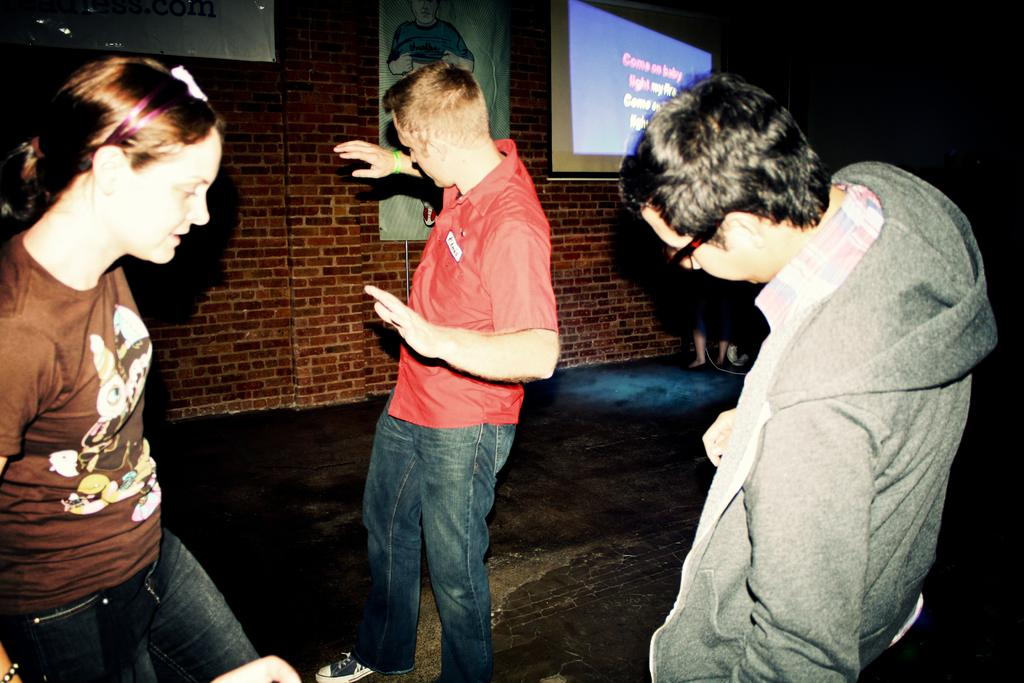Who or what can be seen in the image? There are people in the image. What can be seen in the background of the image? There are posts on a wall in the background of the image. What is the main object in the foreground of the image? There is a projector screen in the image. Is it raining in the image? There is no indication of rain in the image. Are the people in the image being punished? There is no indication of punishment in the image. 